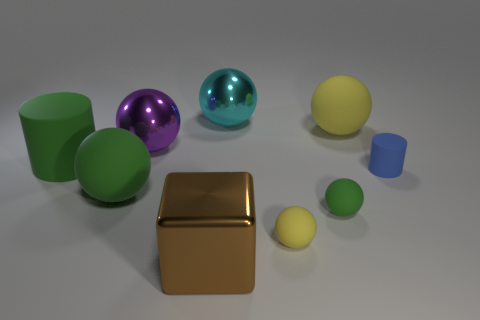Subtract all cyan shiny balls. How many balls are left? 5 Subtract all green balls. How many balls are left? 4 Subtract all purple balls. Subtract all red cubes. How many balls are left? 5 Add 1 large green cylinders. How many objects exist? 10 Subtract all balls. How many objects are left? 3 Add 1 big purple spheres. How many big purple spheres exist? 2 Subtract 0 blue blocks. How many objects are left? 9 Subtract all gray shiny cylinders. Subtract all purple spheres. How many objects are left? 8 Add 4 big green balls. How many big green balls are left? 5 